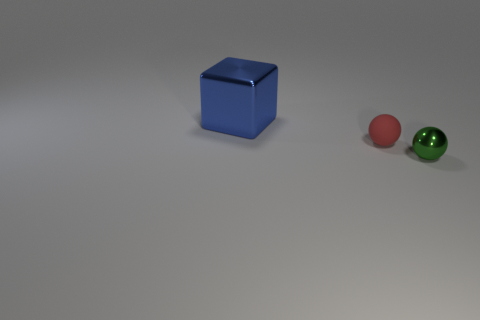Subtract all red blocks. Subtract all brown cylinders. How many blocks are left? 1 Add 1 large brown cubes. How many objects exist? 4 Subtract all cubes. How many objects are left? 2 Subtract 0 brown cubes. How many objects are left? 3 Subtract all big gray things. Subtract all blue objects. How many objects are left? 2 Add 1 tiny red matte things. How many tiny red matte things are left? 2 Add 2 small green matte spheres. How many small green matte spheres exist? 2 